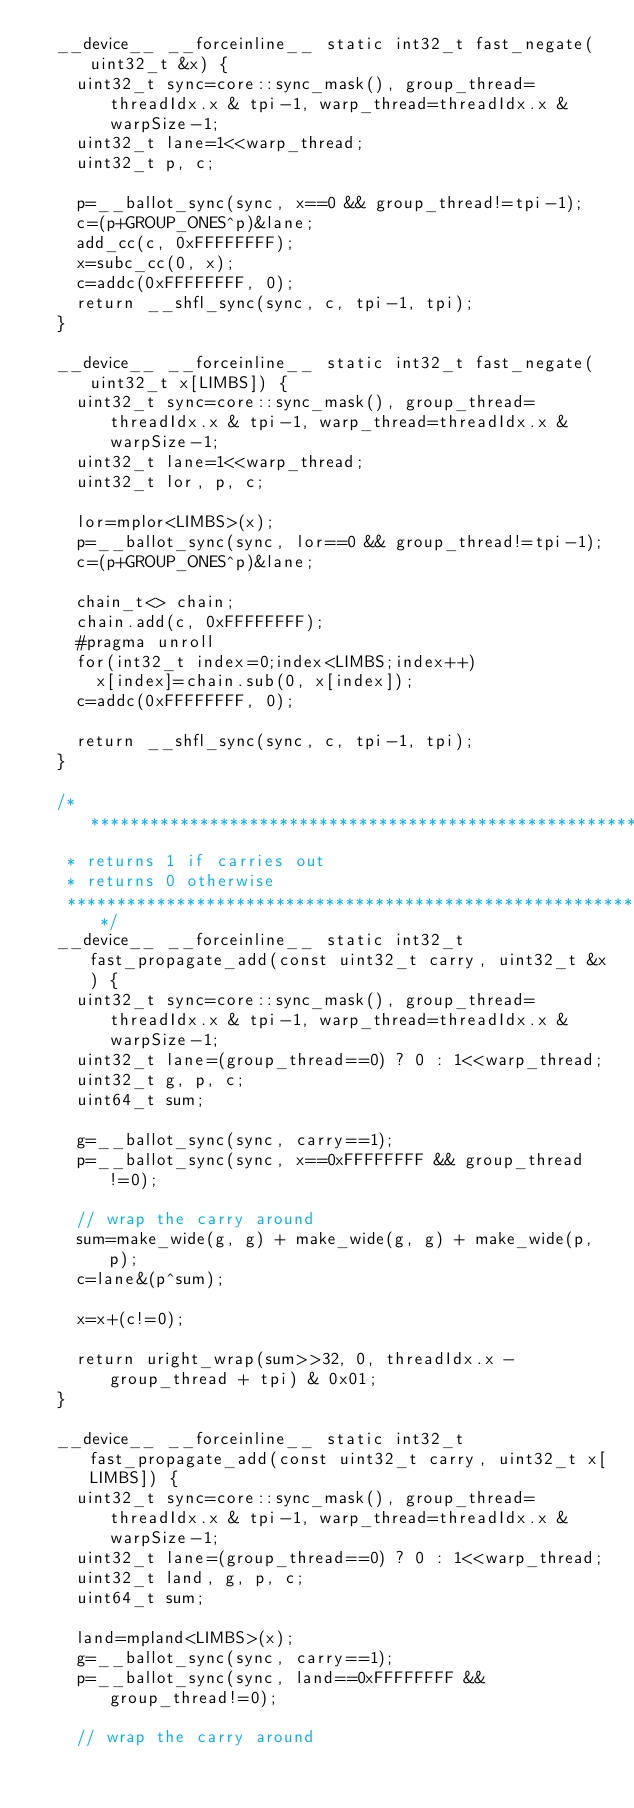<code> <loc_0><loc_0><loc_500><loc_500><_Cuda_>  __device__ __forceinline__ static int32_t fast_negate(uint32_t &x) {
    uint32_t sync=core::sync_mask(), group_thread=threadIdx.x & tpi-1, warp_thread=threadIdx.x & warpSize-1;
    uint32_t lane=1<<warp_thread;
    uint32_t p, c;
  
    p=__ballot_sync(sync, x==0 && group_thread!=tpi-1);
    c=(p+GROUP_ONES^p)&lane;
    add_cc(c, 0xFFFFFFFF);
    x=subc_cc(0, x);
    c=addc(0xFFFFFFFF, 0);
    return __shfl_sync(sync, c, tpi-1, tpi);
  }
  
  __device__ __forceinline__ static int32_t fast_negate(uint32_t x[LIMBS]) {
    uint32_t sync=core::sync_mask(), group_thread=threadIdx.x & tpi-1, warp_thread=threadIdx.x & warpSize-1;
    uint32_t lane=1<<warp_thread;
    uint32_t lor, p, c;
  
    lor=mplor<LIMBS>(x);
    p=__ballot_sync(sync, lor==0 && group_thread!=tpi-1);
    c=(p+GROUP_ONES^p)&lane;
    
    chain_t<> chain;
    chain.add(c, 0xFFFFFFFF);
    #pragma unroll
    for(int32_t index=0;index<LIMBS;index++)
      x[index]=chain.sub(0, x[index]);
    c=addc(0xFFFFFFFF, 0);
    
    return __shfl_sync(sync, c, tpi-1, tpi);
  }
    
  /****************************************************************
   * returns 1 if carries out
   * returns 0 otherwise
   ****************************************************************/
  __device__ __forceinline__ static int32_t fast_propagate_add(const uint32_t carry, uint32_t &x) {
    uint32_t sync=core::sync_mask(), group_thread=threadIdx.x & tpi-1, warp_thread=threadIdx.x & warpSize-1;
    uint32_t lane=(group_thread==0) ? 0 : 1<<warp_thread;
    uint32_t g, p, c; 
    uint64_t sum;
  
    g=__ballot_sync(sync, carry==1);
    p=__ballot_sync(sync, x==0xFFFFFFFF && group_thread!=0);
  
    // wrap the carry around  
    sum=make_wide(g, g) + make_wide(g, g) + make_wide(p, p);
    c=lane&(p^sum);

    x=x+(c!=0);

    return uright_wrap(sum>>32, 0, threadIdx.x - group_thread + tpi) & 0x01;
  }
  
  __device__ __forceinline__ static int32_t fast_propagate_add(const uint32_t carry, uint32_t x[LIMBS]) {
    uint32_t sync=core::sync_mask(), group_thread=threadIdx.x & tpi-1, warp_thread=threadIdx.x & warpSize-1;
    uint32_t lane=(group_thread==0) ? 0 : 1<<warp_thread;
    uint32_t land, g, p, c; 
    uint64_t sum;
    
    land=mpland<LIMBS>(x);
    g=__ballot_sync(sync, carry==1);
    p=__ballot_sync(sync, land==0xFFFFFFFF && group_thread!=0);

    // wrap the carry around  </code> 